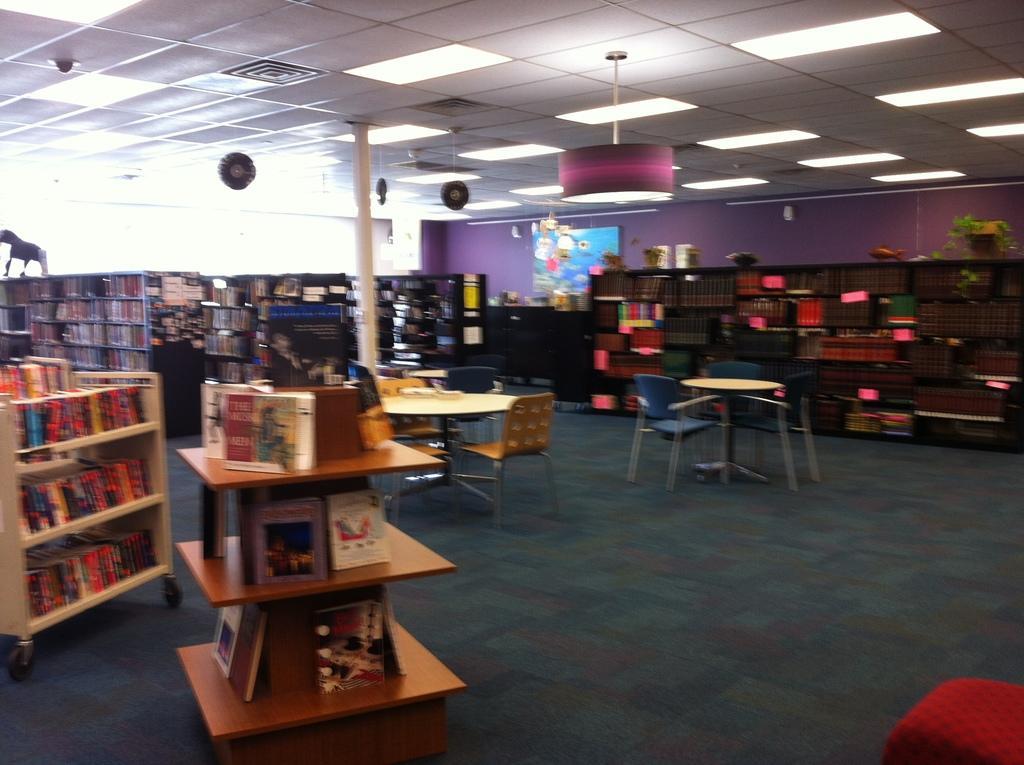Could you give a brief overview of what you see in this image? In this picture I can see chairs and tables. Here I can see shelves which has books and other objects. Here I can see lights on the ceiling. Here I can see a white color pillar and a wall which has some objects attached to it. 